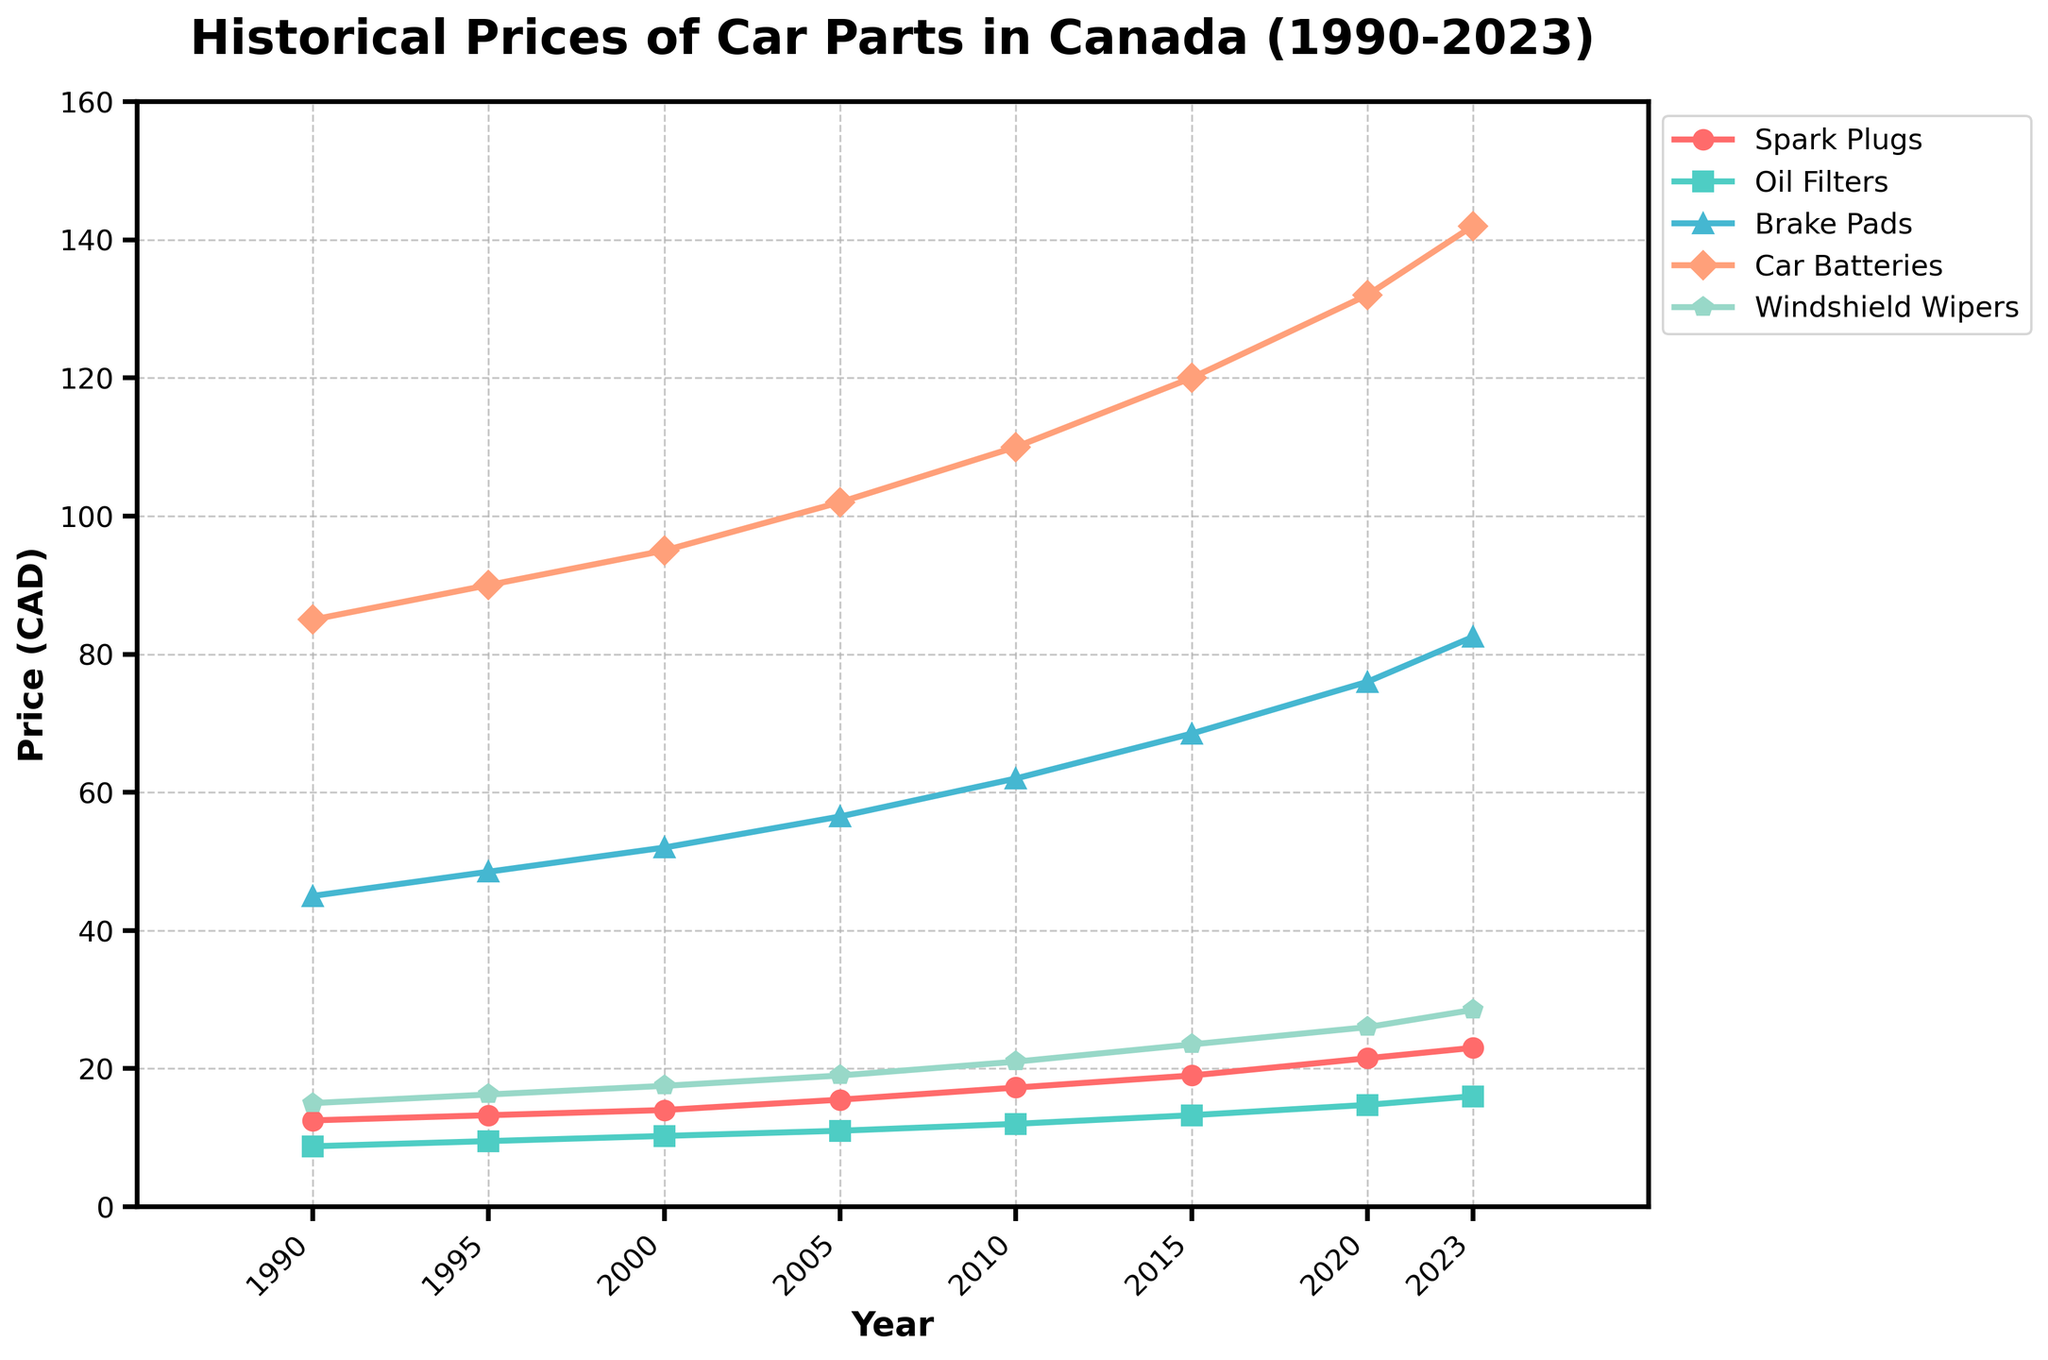What year had the highest price for brake pads? The chart shows the prices for each year, and we need to identify the year with the peak value for brake pads. From the given plot, 2023 shows the highest value for brake pads.
Answer: 2023 How much did the price of car batteries increase from 2000 to 2023? To find the price increase, subtract the price in 2000 from the price in 2023 for car batteries. The price in 2000 was 95.00 CAD, and in 2023 it was 142.00 CAD. Therefore, the increase is 142.00 - 95.00 = 47.00 CAD.
Answer: 47.00 CAD Which car part had the most consistent price increase over the period from 1990 to 2023? Consistent price increase can be visualized by a straight, steady upward trend line. By examining the chart, windshield wipers show a steady and consistent increase over the years compared to other parts.
Answer: Windshield wipers What is the average price of oil filters over the period from 1990 to 2023? The prices for oil filters from 1990 to 2023 are: 8.75, 9.50, 10.25, 11.00, 12.00, 13.25, 14.75, and 16.00 CAD. Average = (8.75 + 9.50 + 10.25 + 11.00 + 12.00 + 13.25 + 14.75 + 16.00) / 8 = 11.94 CAD.
Answer: 11.94 CAD In which year did spark plugs have a price closest to 20 CAD? Checking the prices for spark plugs each year, 2015 had a price of 19.00 CAD, which is the closest to 20 CAD.
Answer: 2015 How does the price change for windshield wipers compare between 2010 and 2020? Subtract the price in 2010 from the price in 2020 for windshield wipers. Price in 2010 is 21.00 CAD and in 2020 is 26.00 CAD. The difference is 26.00 - 21.00 = 5.00 CAD.
Answer: 5.00 CAD Which part had the highest price increase percentage from 2010 to 2023? Calculate the percentage increase for each part by the formula: [(Price in 2023 - Price in 2010) / Price in 2010] x 100. Brake pads: [(82.50 - 62.00) / 62.00] x 100 = 33.06%. Car batteries: [(142.00 - 110.00) / 110.00] x 100 = 29.09%. Windshield wipers: [(28.50 - 21.00) / 21.00] x 100 = 35.71%. Oil filters: [(16.00 - 12.00) / 12.00] x 100 = 33.33%. Spark plugs: [(23.00 - 17.25) / 17.25] x 100 = 33.33%. Windshield wipers have the highest increase percentage.
Answer: Windshield wipers Which car part had the smallest price increase from 1990 to 2023? To find the smallest price increase, we look at the difference between 2023 and 1990 price for each part. Spark plugs: 23.00 - 12.50 = 10.50. Oil filters: 16.00 - 8.75 = 7.25. Brake pads: 82.50 - 45.00 = 37.50. Car batteries: 142.00 - 85.00 = 57.00. Windshield wipers: 28.50 - 15.00 = 13.50. Oil filters had the smallest increase.
Answer: Oil filters 